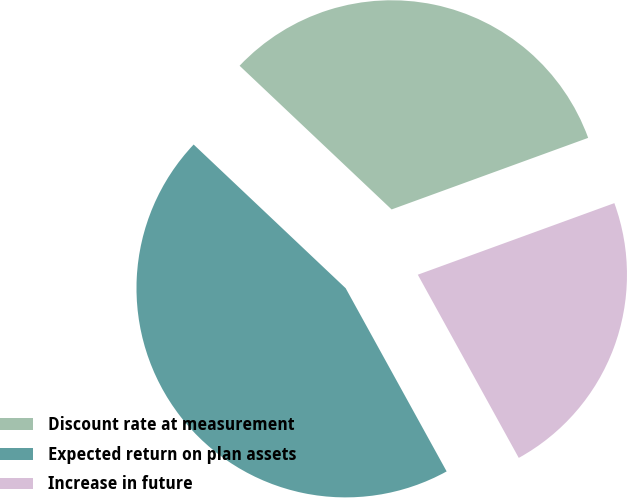<chart> <loc_0><loc_0><loc_500><loc_500><pie_chart><fcel>Discount rate at measurement<fcel>Expected return on plan assets<fcel>Increase in future<nl><fcel>32.39%<fcel>45.07%<fcel>22.54%<nl></chart> 